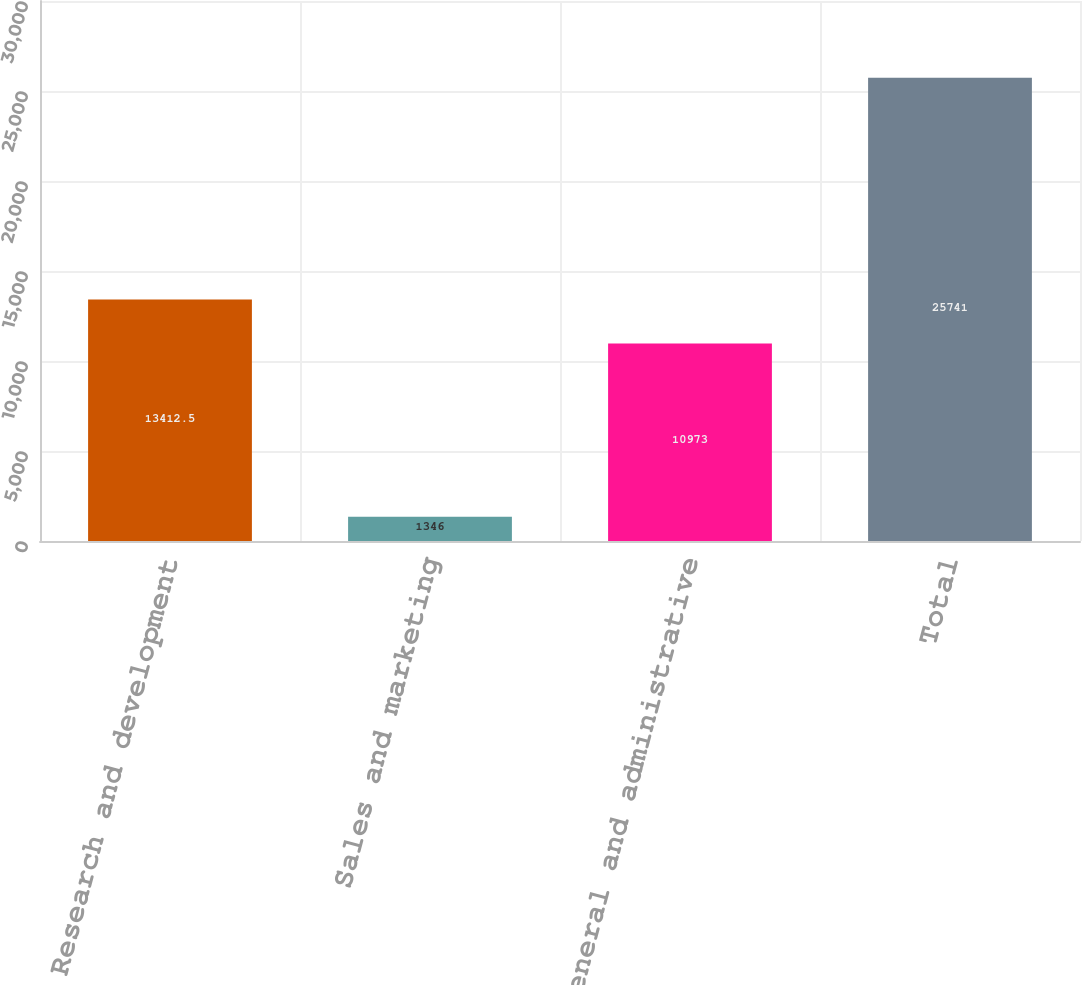Convert chart. <chart><loc_0><loc_0><loc_500><loc_500><bar_chart><fcel>Research and development<fcel>Sales and marketing<fcel>General and administrative<fcel>Total<nl><fcel>13412.5<fcel>1346<fcel>10973<fcel>25741<nl></chart> 